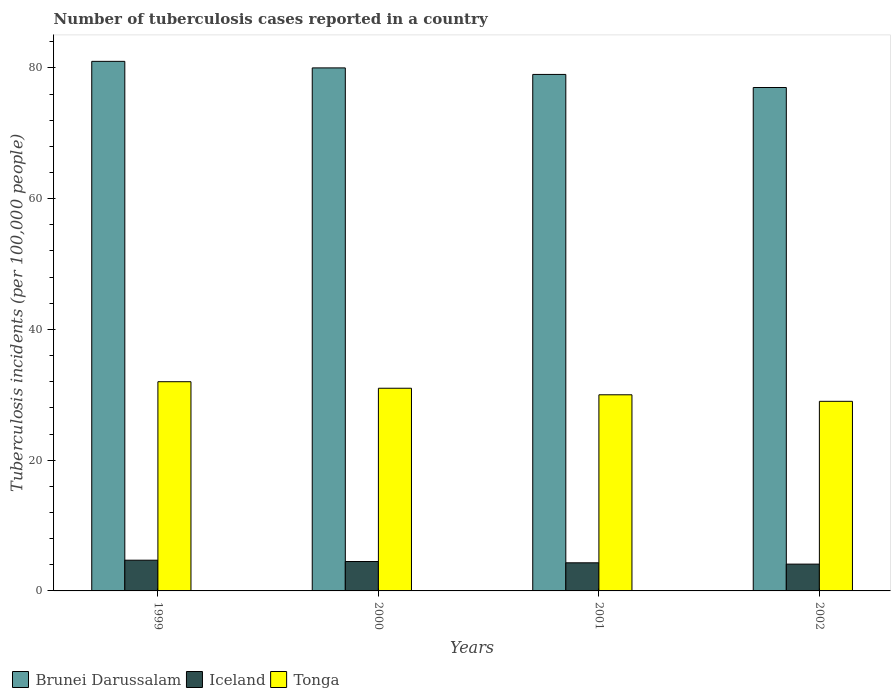How many bars are there on the 3rd tick from the left?
Your response must be concise. 3. How many bars are there on the 4th tick from the right?
Give a very brief answer. 3. What is the label of the 1st group of bars from the left?
Ensure brevity in your answer.  1999. In how many cases, is the number of bars for a given year not equal to the number of legend labels?
Provide a succinct answer. 0. What is the number of tuberculosis cases reported in in Tonga in 2000?
Ensure brevity in your answer.  31. Across all years, what is the maximum number of tuberculosis cases reported in in Brunei Darussalam?
Ensure brevity in your answer.  81. Across all years, what is the minimum number of tuberculosis cases reported in in Brunei Darussalam?
Your answer should be compact. 77. What is the total number of tuberculosis cases reported in in Tonga in the graph?
Your response must be concise. 122. What is the difference between the number of tuberculosis cases reported in in Tonga in 1999 and that in 2001?
Your response must be concise. 2. What is the difference between the number of tuberculosis cases reported in in Brunei Darussalam in 2001 and the number of tuberculosis cases reported in in Iceland in 1999?
Your response must be concise. 74.3. What is the average number of tuberculosis cases reported in in Tonga per year?
Ensure brevity in your answer.  30.5. In the year 2000, what is the difference between the number of tuberculosis cases reported in in Brunei Darussalam and number of tuberculosis cases reported in in Iceland?
Provide a short and direct response. 75.5. In how many years, is the number of tuberculosis cases reported in in Tonga greater than 52?
Offer a terse response. 0. What is the ratio of the number of tuberculosis cases reported in in Tonga in 1999 to that in 2002?
Your answer should be very brief. 1.1. Is the difference between the number of tuberculosis cases reported in in Brunei Darussalam in 2000 and 2001 greater than the difference between the number of tuberculosis cases reported in in Iceland in 2000 and 2001?
Provide a succinct answer. Yes. What is the difference between the highest and the second highest number of tuberculosis cases reported in in Iceland?
Keep it short and to the point. 0.2. What is the difference between the highest and the lowest number of tuberculosis cases reported in in Brunei Darussalam?
Your response must be concise. 4. In how many years, is the number of tuberculosis cases reported in in Brunei Darussalam greater than the average number of tuberculosis cases reported in in Brunei Darussalam taken over all years?
Ensure brevity in your answer.  2. What does the 3rd bar from the left in 2002 represents?
Keep it short and to the point. Tonga. What does the 1st bar from the right in 2000 represents?
Your response must be concise. Tonga. Is it the case that in every year, the sum of the number of tuberculosis cases reported in in Iceland and number of tuberculosis cases reported in in Brunei Darussalam is greater than the number of tuberculosis cases reported in in Tonga?
Your answer should be compact. Yes. How many bars are there?
Ensure brevity in your answer.  12. How many years are there in the graph?
Your response must be concise. 4. Are the values on the major ticks of Y-axis written in scientific E-notation?
Your response must be concise. No. How many legend labels are there?
Provide a short and direct response. 3. What is the title of the graph?
Ensure brevity in your answer.  Number of tuberculosis cases reported in a country. Does "Finland" appear as one of the legend labels in the graph?
Keep it short and to the point. No. What is the label or title of the X-axis?
Provide a succinct answer. Years. What is the label or title of the Y-axis?
Ensure brevity in your answer.  Tuberculosis incidents (per 100,0 people). What is the Tuberculosis incidents (per 100,000 people) of Iceland in 1999?
Keep it short and to the point. 4.7. What is the Tuberculosis incidents (per 100,000 people) of Tonga in 2000?
Keep it short and to the point. 31. What is the Tuberculosis incidents (per 100,000 people) in Brunei Darussalam in 2001?
Offer a terse response. 79. What is the Tuberculosis incidents (per 100,000 people) in Iceland in 2001?
Provide a succinct answer. 4.3. Across all years, what is the maximum Tuberculosis incidents (per 100,000 people) of Brunei Darussalam?
Offer a terse response. 81. Across all years, what is the maximum Tuberculosis incidents (per 100,000 people) of Iceland?
Provide a short and direct response. 4.7. Across all years, what is the maximum Tuberculosis incidents (per 100,000 people) in Tonga?
Provide a succinct answer. 32. Across all years, what is the minimum Tuberculosis incidents (per 100,000 people) in Tonga?
Provide a succinct answer. 29. What is the total Tuberculosis incidents (per 100,000 people) in Brunei Darussalam in the graph?
Keep it short and to the point. 317. What is the total Tuberculosis incidents (per 100,000 people) of Iceland in the graph?
Offer a very short reply. 17.6. What is the total Tuberculosis incidents (per 100,000 people) in Tonga in the graph?
Make the answer very short. 122. What is the difference between the Tuberculosis incidents (per 100,000 people) of Brunei Darussalam in 1999 and that in 2001?
Make the answer very short. 2. What is the difference between the Tuberculosis incidents (per 100,000 people) in Brunei Darussalam in 1999 and that in 2002?
Keep it short and to the point. 4. What is the difference between the Tuberculosis incidents (per 100,000 people) in Iceland in 1999 and that in 2002?
Your response must be concise. 0.6. What is the difference between the Tuberculosis incidents (per 100,000 people) in Brunei Darussalam in 2000 and that in 2001?
Your answer should be very brief. 1. What is the difference between the Tuberculosis incidents (per 100,000 people) of Tonga in 2000 and that in 2001?
Ensure brevity in your answer.  1. What is the difference between the Tuberculosis incidents (per 100,000 people) in Iceland in 2000 and that in 2002?
Your response must be concise. 0.4. What is the difference between the Tuberculosis incidents (per 100,000 people) of Tonga in 2000 and that in 2002?
Provide a short and direct response. 2. What is the difference between the Tuberculosis incidents (per 100,000 people) of Iceland in 2001 and that in 2002?
Offer a very short reply. 0.2. What is the difference between the Tuberculosis incidents (per 100,000 people) in Brunei Darussalam in 1999 and the Tuberculosis incidents (per 100,000 people) in Iceland in 2000?
Your response must be concise. 76.5. What is the difference between the Tuberculosis incidents (per 100,000 people) in Iceland in 1999 and the Tuberculosis incidents (per 100,000 people) in Tonga in 2000?
Ensure brevity in your answer.  -26.3. What is the difference between the Tuberculosis incidents (per 100,000 people) of Brunei Darussalam in 1999 and the Tuberculosis incidents (per 100,000 people) of Iceland in 2001?
Provide a succinct answer. 76.7. What is the difference between the Tuberculosis incidents (per 100,000 people) of Iceland in 1999 and the Tuberculosis incidents (per 100,000 people) of Tonga in 2001?
Your response must be concise. -25.3. What is the difference between the Tuberculosis incidents (per 100,000 people) in Brunei Darussalam in 1999 and the Tuberculosis incidents (per 100,000 people) in Iceland in 2002?
Make the answer very short. 76.9. What is the difference between the Tuberculosis incidents (per 100,000 people) of Brunei Darussalam in 1999 and the Tuberculosis incidents (per 100,000 people) of Tonga in 2002?
Your answer should be very brief. 52. What is the difference between the Tuberculosis incidents (per 100,000 people) of Iceland in 1999 and the Tuberculosis incidents (per 100,000 people) of Tonga in 2002?
Make the answer very short. -24.3. What is the difference between the Tuberculosis incidents (per 100,000 people) of Brunei Darussalam in 2000 and the Tuberculosis incidents (per 100,000 people) of Iceland in 2001?
Keep it short and to the point. 75.7. What is the difference between the Tuberculosis incidents (per 100,000 people) in Brunei Darussalam in 2000 and the Tuberculosis incidents (per 100,000 people) in Tonga in 2001?
Your answer should be compact. 50. What is the difference between the Tuberculosis incidents (per 100,000 people) in Iceland in 2000 and the Tuberculosis incidents (per 100,000 people) in Tonga in 2001?
Your answer should be very brief. -25.5. What is the difference between the Tuberculosis incidents (per 100,000 people) of Brunei Darussalam in 2000 and the Tuberculosis incidents (per 100,000 people) of Iceland in 2002?
Provide a short and direct response. 75.9. What is the difference between the Tuberculosis incidents (per 100,000 people) in Iceland in 2000 and the Tuberculosis incidents (per 100,000 people) in Tonga in 2002?
Provide a succinct answer. -24.5. What is the difference between the Tuberculosis incidents (per 100,000 people) of Brunei Darussalam in 2001 and the Tuberculosis incidents (per 100,000 people) of Iceland in 2002?
Ensure brevity in your answer.  74.9. What is the difference between the Tuberculosis incidents (per 100,000 people) of Brunei Darussalam in 2001 and the Tuberculosis incidents (per 100,000 people) of Tonga in 2002?
Provide a short and direct response. 50. What is the difference between the Tuberculosis incidents (per 100,000 people) of Iceland in 2001 and the Tuberculosis incidents (per 100,000 people) of Tonga in 2002?
Your response must be concise. -24.7. What is the average Tuberculosis incidents (per 100,000 people) of Brunei Darussalam per year?
Your answer should be compact. 79.25. What is the average Tuberculosis incidents (per 100,000 people) in Tonga per year?
Make the answer very short. 30.5. In the year 1999, what is the difference between the Tuberculosis incidents (per 100,000 people) in Brunei Darussalam and Tuberculosis incidents (per 100,000 people) in Iceland?
Provide a succinct answer. 76.3. In the year 1999, what is the difference between the Tuberculosis incidents (per 100,000 people) in Iceland and Tuberculosis incidents (per 100,000 people) in Tonga?
Provide a short and direct response. -27.3. In the year 2000, what is the difference between the Tuberculosis incidents (per 100,000 people) of Brunei Darussalam and Tuberculosis incidents (per 100,000 people) of Iceland?
Your answer should be compact. 75.5. In the year 2000, what is the difference between the Tuberculosis incidents (per 100,000 people) in Iceland and Tuberculosis incidents (per 100,000 people) in Tonga?
Ensure brevity in your answer.  -26.5. In the year 2001, what is the difference between the Tuberculosis incidents (per 100,000 people) in Brunei Darussalam and Tuberculosis incidents (per 100,000 people) in Iceland?
Provide a succinct answer. 74.7. In the year 2001, what is the difference between the Tuberculosis incidents (per 100,000 people) in Iceland and Tuberculosis incidents (per 100,000 people) in Tonga?
Your answer should be compact. -25.7. In the year 2002, what is the difference between the Tuberculosis incidents (per 100,000 people) in Brunei Darussalam and Tuberculosis incidents (per 100,000 people) in Iceland?
Keep it short and to the point. 72.9. In the year 2002, what is the difference between the Tuberculosis incidents (per 100,000 people) in Brunei Darussalam and Tuberculosis incidents (per 100,000 people) in Tonga?
Offer a very short reply. 48. In the year 2002, what is the difference between the Tuberculosis incidents (per 100,000 people) in Iceland and Tuberculosis incidents (per 100,000 people) in Tonga?
Your answer should be very brief. -24.9. What is the ratio of the Tuberculosis incidents (per 100,000 people) of Brunei Darussalam in 1999 to that in 2000?
Make the answer very short. 1.01. What is the ratio of the Tuberculosis incidents (per 100,000 people) in Iceland in 1999 to that in 2000?
Ensure brevity in your answer.  1.04. What is the ratio of the Tuberculosis incidents (per 100,000 people) in Tonga in 1999 to that in 2000?
Provide a succinct answer. 1.03. What is the ratio of the Tuberculosis incidents (per 100,000 people) in Brunei Darussalam in 1999 to that in 2001?
Keep it short and to the point. 1.03. What is the ratio of the Tuberculosis incidents (per 100,000 people) in Iceland in 1999 to that in 2001?
Provide a succinct answer. 1.09. What is the ratio of the Tuberculosis incidents (per 100,000 people) of Tonga in 1999 to that in 2001?
Your answer should be very brief. 1.07. What is the ratio of the Tuberculosis incidents (per 100,000 people) of Brunei Darussalam in 1999 to that in 2002?
Give a very brief answer. 1.05. What is the ratio of the Tuberculosis incidents (per 100,000 people) in Iceland in 1999 to that in 2002?
Make the answer very short. 1.15. What is the ratio of the Tuberculosis incidents (per 100,000 people) in Tonga in 1999 to that in 2002?
Provide a short and direct response. 1.1. What is the ratio of the Tuberculosis incidents (per 100,000 people) of Brunei Darussalam in 2000 to that in 2001?
Your response must be concise. 1.01. What is the ratio of the Tuberculosis incidents (per 100,000 people) of Iceland in 2000 to that in 2001?
Your response must be concise. 1.05. What is the ratio of the Tuberculosis incidents (per 100,000 people) in Tonga in 2000 to that in 2001?
Offer a terse response. 1.03. What is the ratio of the Tuberculosis incidents (per 100,000 people) of Brunei Darussalam in 2000 to that in 2002?
Provide a succinct answer. 1.04. What is the ratio of the Tuberculosis incidents (per 100,000 people) of Iceland in 2000 to that in 2002?
Ensure brevity in your answer.  1.1. What is the ratio of the Tuberculosis incidents (per 100,000 people) of Tonga in 2000 to that in 2002?
Ensure brevity in your answer.  1.07. What is the ratio of the Tuberculosis incidents (per 100,000 people) in Iceland in 2001 to that in 2002?
Your response must be concise. 1.05. What is the ratio of the Tuberculosis incidents (per 100,000 people) in Tonga in 2001 to that in 2002?
Keep it short and to the point. 1.03. What is the difference between the highest and the second highest Tuberculosis incidents (per 100,000 people) in Tonga?
Ensure brevity in your answer.  1. What is the difference between the highest and the lowest Tuberculosis incidents (per 100,000 people) in Brunei Darussalam?
Your answer should be very brief. 4. What is the difference between the highest and the lowest Tuberculosis incidents (per 100,000 people) in Tonga?
Offer a very short reply. 3. 